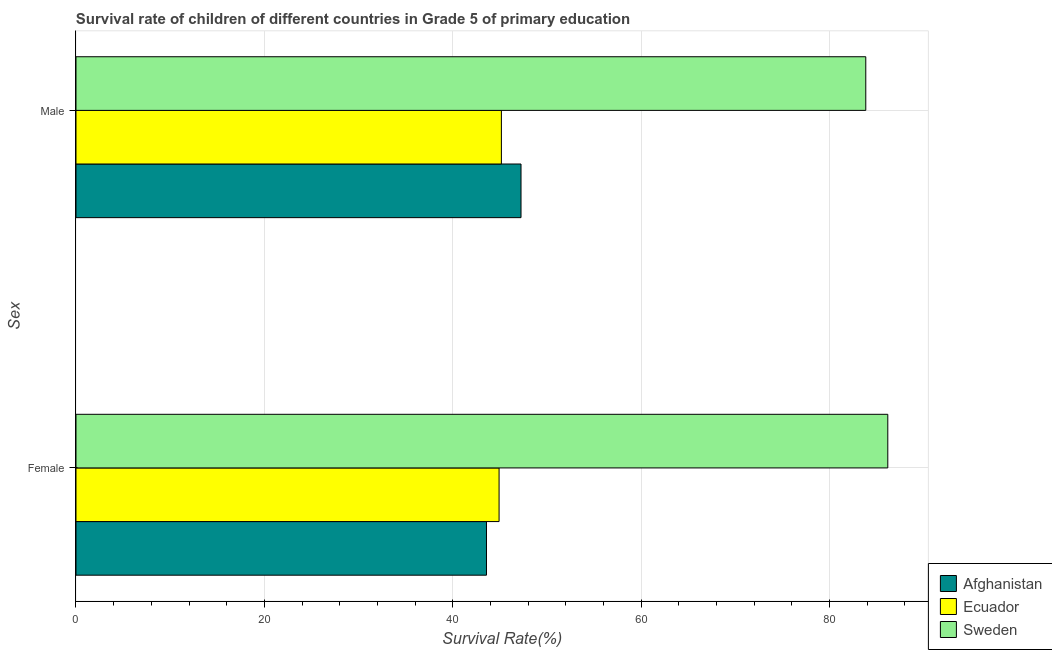Are the number of bars per tick equal to the number of legend labels?
Ensure brevity in your answer.  Yes. Are the number of bars on each tick of the Y-axis equal?
Your response must be concise. Yes. How many bars are there on the 1st tick from the top?
Keep it short and to the point. 3. What is the label of the 2nd group of bars from the top?
Provide a short and direct response. Female. What is the survival rate of male students in primary education in Ecuador?
Provide a short and direct response. 45.16. Across all countries, what is the maximum survival rate of female students in primary education?
Offer a very short reply. 86.18. Across all countries, what is the minimum survival rate of female students in primary education?
Ensure brevity in your answer.  43.58. In which country was the survival rate of female students in primary education minimum?
Provide a succinct answer. Afghanistan. What is the total survival rate of male students in primary education in the graph?
Your response must be concise. 176.25. What is the difference between the survival rate of male students in primary education in Sweden and that in Ecuador?
Ensure brevity in your answer.  38.69. What is the difference between the survival rate of male students in primary education in Ecuador and the survival rate of female students in primary education in Afghanistan?
Your response must be concise. 1.58. What is the average survival rate of female students in primary education per country?
Give a very brief answer. 58.23. What is the difference between the survival rate of male students in primary education and survival rate of female students in primary education in Afghanistan?
Your answer should be very brief. 3.67. In how many countries, is the survival rate of female students in primary education greater than 76 %?
Offer a terse response. 1. What is the ratio of the survival rate of female students in primary education in Sweden to that in Afghanistan?
Provide a short and direct response. 1.98. In how many countries, is the survival rate of female students in primary education greater than the average survival rate of female students in primary education taken over all countries?
Ensure brevity in your answer.  1. What does the 1st bar from the bottom in Female represents?
Your answer should be compact. Afghanistan. How many bars are there?
Make the answer very short. 6. Are all the bars in the graph horizontal?
Give a very brief answer. Yes. What is the difference between two consecutive major ticks on the X-axis?
Give a very brief answer. 20. Does the graph contain any zero values?
Offer a very short reply. No. Where does the legend appear in the graph?
Provide a succinct answer. Bottom right. What is the title of the graph?
Keep it short and to the point. Survival rate of children of different countries in Grade 5 of primary education. What is the label or title of the X-axis?
Your response must be concise. Survival Rate(%). What is the label or title of the Y-axis?
Provide a short and direct response. Sex. What is the Survival Rate(%) of Afghanistan in Female?
Provide a succinct answer. 43.58. What is the Survival Rate(%) of Ecuador in Female?
Your response must be concise. 44.92. What is the Survival Rate(%) in Sweden in Female?
Keep it short and to the point. 86.18. What is the Survival Rate(%) in Afghanistan in Male?
Keep it short and to the point. 47.25. What is the Survival Rate(%) in Ecuador in Male?
Your response must be concise. 45.16. What is the Survival Rate(%) of Sweden in Male?
Give a very brief answer. 83.85. Across all Sex, what is the maximum Survival Rate(%) in Afghanistan?
Your response must be concise. 47.25. Across all Sex, what is the maximum Survival Rate(%) in Ecuador?
Your response must be concise. 45.16. Across all Sex, what is the maximum Survival Rate(%) in Sweden?
Your answer should be compact. 86.18. Across all Sex, what is the minimum Survival Rate(%) of Afghanistan?
Provide a succinct answer. 43.58. Across all Sex, what is the minimum Survival Rate(%) of Ecuador?
Ensure brevity in your answer.  44.92. Across all Sex, what is the minimum Survival Rate(%) in Sweden?
Provide a short and direct response. 83.85. What is the total Survival Rate(%) in Afghanistan in the graph?
Provide a succinct answer. 90.82. What is the total Survival Rate(%) in Ecuador in the graph?
Make the answer very short. 90.08. What is the total Survival Rate(%) of Sweden in the graph?
Provide a succinct answer. 170.03. What is the difference between the Survival Rate(%) in Afghanistan in Female and that in Male?
Keep it short and to the point. -3.67. What is the difference between the Survival Rate(%) in Ecuador in Female and that in Male?
Offer a terse response. -0.24. What is the difference between the Survival Rate(%) of Sweden in Female and that in Male?
Provide a short and direct response. 2.34. What is the difference between the Survival Rate(%) of Afghanistan in Female and the Survival Rate(%) of Ecuador in Male?
Offer a very short reply. -1.58. What is the difference between the Survival Rate(%) in Afghanistan in Female and the Survival Rate(%) in Sweden in Male?
Make the answer very short. -40.27. What is the difference between the Survival Rate(%) in Ecuador in Female and the Survival Rate(%) in Sweden in Male?
Your response must be concise. -38.93. What is the average Survival Rate(%) of Afghanistan per Sex?
Keep it short and to the point. 45.41. What is the average Survival Rate(%) in Ecuador per Sex?
Give a very brief answer. 45.04. What is the average Survival Rate(%) of Sweden per Sex?
Your response must be concise. 85.02. What is the difference between the Survival Rate(%) in Afghanistan and Survival Rate(%) in Ecuador in Female?
Provide a short and direct response. -1.34. What is the difference between the Survival Rate(%) of Afghanistan and Survival Rate(%) of Sweden in Female?
Offer a terse response. -42.6. What is the difference between the Survival Rate(%) of Ecuador and Survival Rate(%) of Sweden in Female?
Offer a very short reply. -41.27. What is the difference between the Survival Rate(%) in Afghanistan and Survival Rate(%) in Ecuador in Male?
Ensure brevity in your answer.  2.08. What is the difference between the Survival Rate(%) of Afghanistan and Survival Rate(%) of Sweden in Male?
Provide a short and direct response. -36.6. What is the difference between the Survival Rate(%) in Ecuador and Survival Rate(%) in Sweden in Male?
Your response must be concise. -38.69. What is the ratio of the Survival Rate(%) in Afghanistan in Female to that in Male?
Your response must be concise. 0.92. What is the ratio of the Survival Rate(%) of Sweden in Female to that in Male?
Provide a short and direct response. 1.03. What is the difference between the highest and the second highest Survival Rate(%) of Afghanistan?
Offer a terse response. 3.67. What is the difference between the highest and the second highest Survival Rate(%) in Ecuador?
Your answer should be very brief. 0.24. What is the difference between the highest and the second highest Survival Rate(%) in Sweden?
Your answer should be compact. 2.34. What is the difference between the highest and the lowest Survival Rate(%) in Afghanistan?
Offer a very short reply. 3.67. What is the difference between the highest and the lowest Survival Rate(%) in Ecuador?
Offer a terse response. 0.24. What is the difference between the highest and the lowest Survival Rate(%) in Sweden?
Provide a succinct answer. 2.34. 